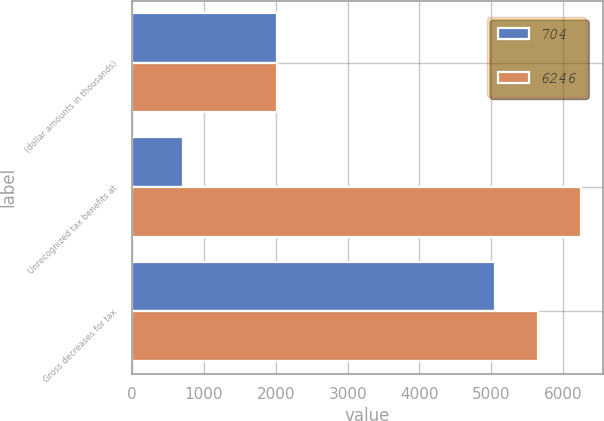Convert chart to OTSL. <chart><loc_0><loc_0><loc_500><loc_500><stacked_bar_chart><ecel><fcel>(dollar amounts in thousands)<fcel>Unrecognized tax benefits at<fcel>Gross decreases for tax<nl><fcel>704<fcel>2013<fcel>704<fcel>5048<nl><fcel>6246<fcel>2012<fcel>6246<fcel>5650<nl></chart> 